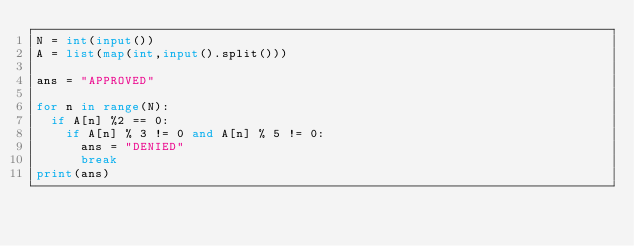Convert code to text. <code><loc_0><loc_0><loc_500><loc_500><_Python_>N = int(input())
A = list(map(int,input().split()))

ans = "APPROVED"

for n in range(N):
  if A[n] %2 == 0:
    if A[n] % 3 != 0 and A[n] % 5 != 0:
      ans = "DENIED"
      break
print(ans)</code> 